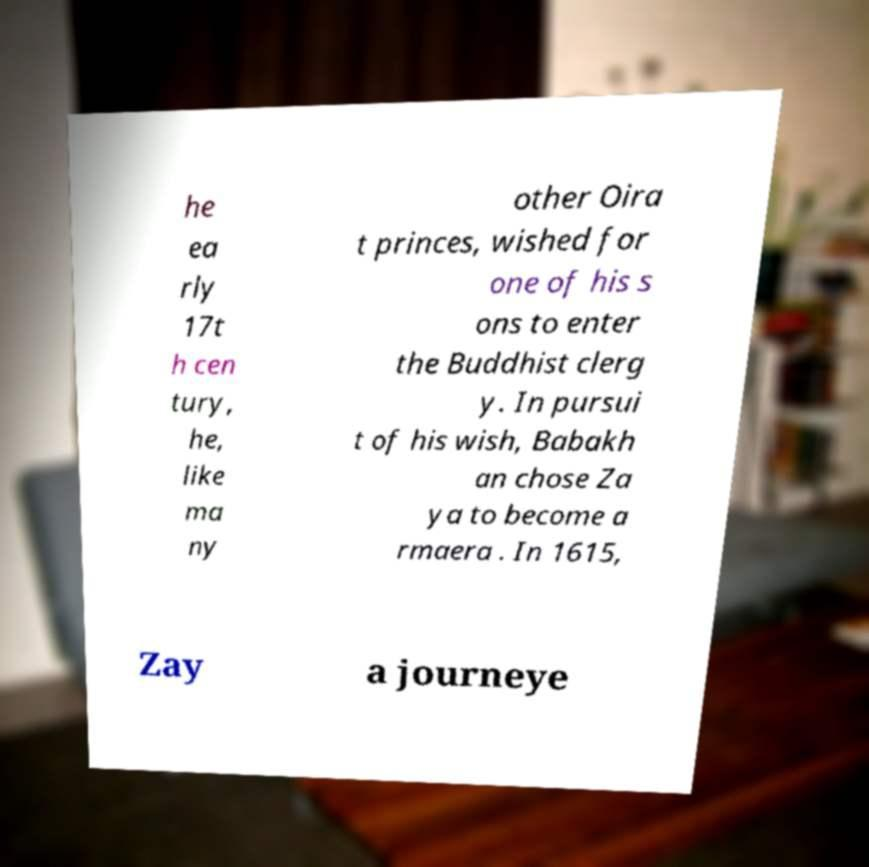Please read and relay the text visible in this image. What does it say? he ea rly 17t h cen tury, he, like ma ny other Oira t princes, wished for one of his s ons to enter the Buddhist clerg y. In pursui t of his wish, Babakh an chose Za ya to become a rmaera . In 1615, Zay a journeye 